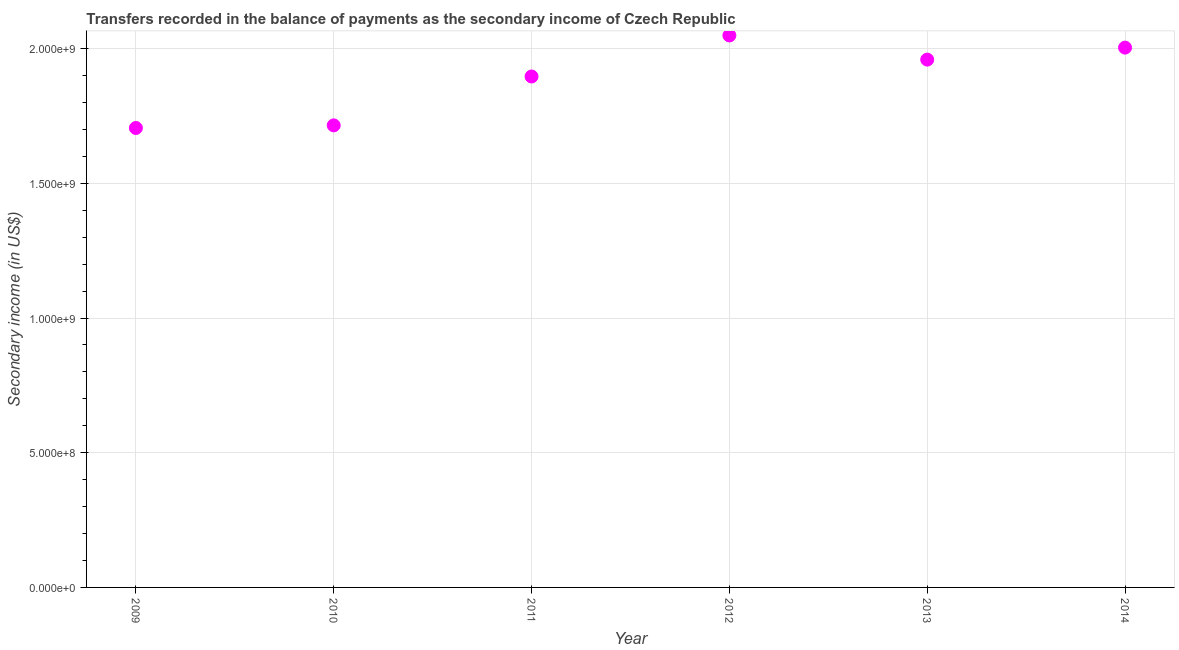What is the amount of secondary income in 2011?
Your response must be concise. 1.90e+09. Across all years, what is the maximum amount of secondary income?
Provide a short and direct response. 2.05e+09. Across all years, what is the minimum amount of secondary income?
Ensure brevity in your answer.  1.71e+09. In which year was the amount of secondary income maximum?
Keep it short and to the point. 2012. What is the sum of the amount of secondary income?
Provide a succinct answer. 1.13e+1. What is the difference between the amount of secondary income in 2011 and 2013?
Your answer should be very brief. -6.27e+07. What is the average amount of secondary income per year?
Provide a succinct answer. 1.89e+09. What is the median amount of secondary income?
Provide a succinct answer. 1.93e+09. What is the ratio of the amount of secondary income in 2009 to that in 2013?
Keep it short and to the point. 0.87. Is the difference between the amount of secondary income in 2010 and 2012 greater than the difference between any two years?
Provide a succinct answer. No. What is the difference between the highest and the second highest amount of secondary income?
Provide a short and direct response. 4.51e+07. Is the sum of the amount of secondary income in 2010 and 2012 greater than the maximum amount of secondary income across all years?
Keep it short and to the point. Yes. What is the difference between the highest and the lowest amount of secondary income?
Keep it short and to the point. 3.44e+08. In how many years, is the amount of secondary income greater than the average amount of secondary income taken over all years?
Provide a succinct answer. 4. Does the amount of secondary income monotonically increase over the years?
Your answer should be very brief. No. How many dotlines are there?
Keep it short and to the point. 1. What is the title of the graph?
Offer a very short reply. Transfers recorded in the balance of payments as the secondary income of Czech Republic. What is the label or title of the X-axis?
Keep it short and to the point. Year. What is the label or title of the Y-axis?
Your answer should be compact. Secondary income (in US$). What is the Secondary income (in US$) in 2009?
Keep it short and to the point. 1.71e+09. What is the Secondary income (in US$) in 2010?
Keep it short and to the point. 1.72e+09. What is the Secondary income (in US$) in 2011?
Offer a very short reply. 1.90e+09. What is the Secondary income (in US$) in 2012?
Ensure brevity in your answer.  2.05e+09. What is the Secondary income (in US$) in 2013?
Offer a very short reply. 1.96e+09. What is the Secondary income (in US$) in 2014?
Give a very brief answer. 2.00e+09. What is the difference between the Secondary income (in US$) in 2009 and 2010?
Ensure brevity in your answer.  -9.73e+06. What is the difference between the Secondary income (in US$) in 2009 and 2011?
Offer a terse response. -1.91e+08. What is the difference between the Secondary income (in US$) in 2009 and 2012?
Your answer should be very brief. -3.44e+08. What is the difference between the Secondary income (in US$) in 2009 and 2013?
Offer a terse response. -2.54e+08. What is the difference between the Secondary income (in US$) in 2009 and 2014?
Your answer should be compact. -2.98e+08. What is the difference between the Secondary income (in US$) in 2010 and 2011?
Provide a succinct answer. -1.81e+08. What is the difference between the Secondary income (in US$) in 2010 and 2012?
Make the answer very short. -3.34e+08. What is the difference between the Secondary income (in US$) in 2010 and 2013?
Provide a short and direct response. -2.44e+08. What is the difference between the Secondary income (in US$) in 2010 and 2014?
Make the answer very short. -2.89e+08. What is the difference between the Secondary income (in US$) in 2011 and 2012?
Your response must be concise. -1.52e+08. What is the difference between the Secondary income (in US$) in 2011 and 2013?
Your response must be concise. -6.27e+07. What is the difference between the Secondary income (in US$) in 2011 and 2014?
Provide a succinct answer. -1.07e+08. What is the difference between the Secondary income (in US$) in 2012 and 2013?
Keep it short and to the point. 8.97e+07. What is the difference between the Secondary income (in US$) in 2012 and 2014?
Provide a succinct answer. 4.51e+07. What is the difference between the Secondary income (in US$) in 2013 and 2014?
Offer a terse response. -4.45e+07. What is the ratio of the Secondary income (in US$) in 2009 to that in 2010?
Ensure brevity in your answer.  0.99. What is the ratio of the Secondary income (in US$) in 2009 to that in 2011?
Keep it short and to the point. 0.9. What is the ratio of the Secondary income (in US$) in 2009 to that in 2012?
Your response must be concise. 0.83. What is the ratio of the Secondary income (in US$) in 2009 to that in 2013?
Give a very brief answer. 0.87. What is the ratio of the Secondary income (in US$) in 2009 to that in 2014?
Make the answer very short. 0.85. What is the ratio of the Secondary income (in US$) in 2010 to that in 2011?
Offer a very short reply. 0.9. What is the ratio of the Secondary income (in US$) in 2010 to that in 2012?
Your answer should be very brief. 0.84. What is the ratio of the Secondary income (in US$) in 2010 to that in 2013?
Ensure brevity in your answer.  0.88. What is the ratio of the Secondary income (in US$) in 2010 to that in 2014?
Your answer should be compact. 0.86. What is the ratio of the Secondary income (in US$) in 2011 to that in 2012?
Your answer should be compact. 0.93. What is the ratio of the Secondary income (in US$) in 2011 to that in 2013?
Ensure brevity in your answer.  0.97. What is the ratio of the Secondary income (in US$) in 2011 to that in 2014?
Offer a terse response. 0.95. What is the ratio of the Secondary income (in US$) in 2012 to that in 2013?
Make the answer very short. 1.05. 